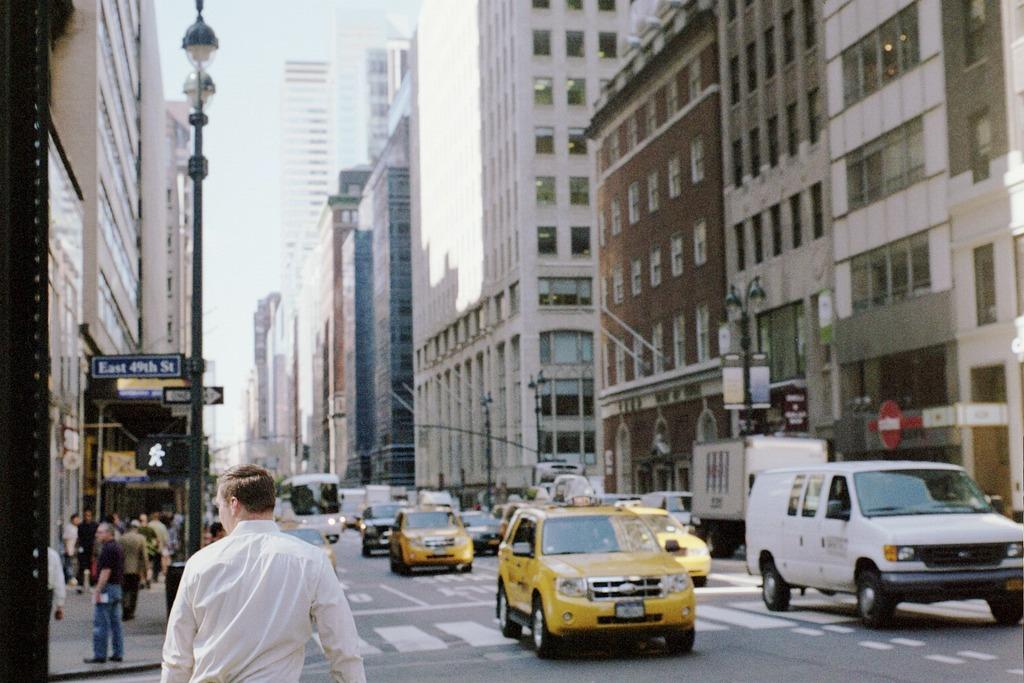Provide a one-sentence caption for the provided image. traffic with a taxi cab in front of a street sign that says East 49th street one way. 